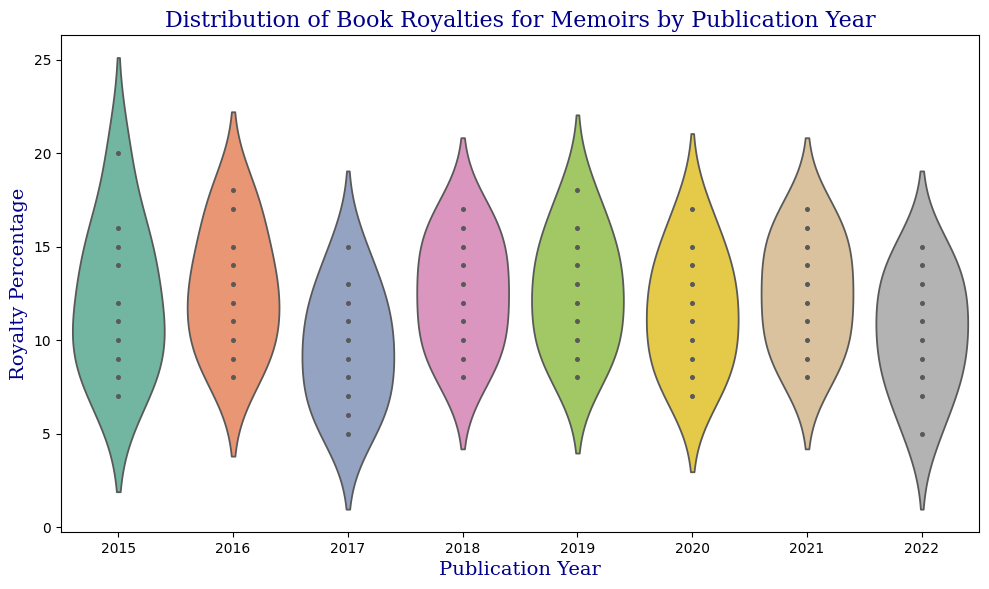What's the median royalty percentage for memoirs published in 2018? To find the median royalty percentage for memoirs published in 2018, locate the middle value in the sorted list of royalties for that year. The sorted values are 8, 9, 10, 11, 12, 13, 14, 15, 16, 17. The median is the average of the 5th and 6th values, which are 12 and 13. Therefore, the median is (12 + 13) / 2 = 12.5
Answer: 12.5 Which publication year has the widest range of royalty percentages? To determine the year with the widest range, identify the year with the largest difference between the maximum and minimum royalty percentages. For 2015: range is 20 - 7 = 13. For 2016: range is 18 - 8 = 10. For 2017: range is 15 - 5 = 10. For 2018: range is 17 - 8 = 9. For 2019: range is 18 - 8 = 10. For 2020: range is 17 - 7 = 10. For 2021: range is 17 - 8 = 9. For 2022: range is 15 - 5 = 10. Thus, 2015 has the widest range of 13.
Answer: 2015 In which year are the royalty percentages most evenly distributed? To determine the year with the most even distribution, look for the year with the most uniform spread of data points within its violin plot. A more evenly distributed violin plot will have a less skewed or more symmetrical shape. Based on visual inspection, 2021 has a fairly symmetrical plot, suggesting an even distribution.
Answer: 2021 Between 2017 and 2019, which year has a higher median royalty percentage? First, find the median royalty for each year. For 2017, sorted values are 5, 6, 7, 8, 9, 10, 11, 12, 13, 15. The median is (9 + 10) / 2 = 9.5. For 2018: median is 12.5 (as calculated before). For 2019: sorted values are 8, 9, 10, 11, 12, 13, 14, 15, 16, 18. The median is (13 + 14) / 2 = 13.5. Therefore, 2019 has the highest median of 13.5 compared to 9.5 in 2017.
Answer: 2019 Which publication year shows evidence of outliers in royalties? To identify outliers visually, look for individual data points separated from the main body of the violin plot. In 2017, 2015, and 2019, there are points that appear separated from the main cluster of datapoints, indicating possible outliers.
Answer: 2015, 2017, 2019 